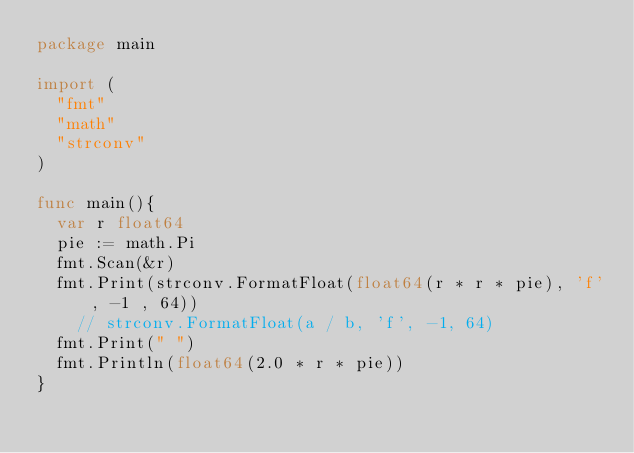Convert code to text. <code><loc_0><loc_0><loc_500><loc_500><_Go_>package main

import (
	"fmt"
	"math"
	"strconv"
)

func main(){
	var r float64
	pie := math.Pi
	fmt.Scan(&r)
	fmt.Print(strconv.FormatFloat(float64(r * r * pie), 'f', -1 , 64))
    // strconv.FormatFloat(a / b, 'f', -1, 64)
	fmt.Print(" ")
	fmt.Println(float64(2.0 * r * pie))
}

</code> 